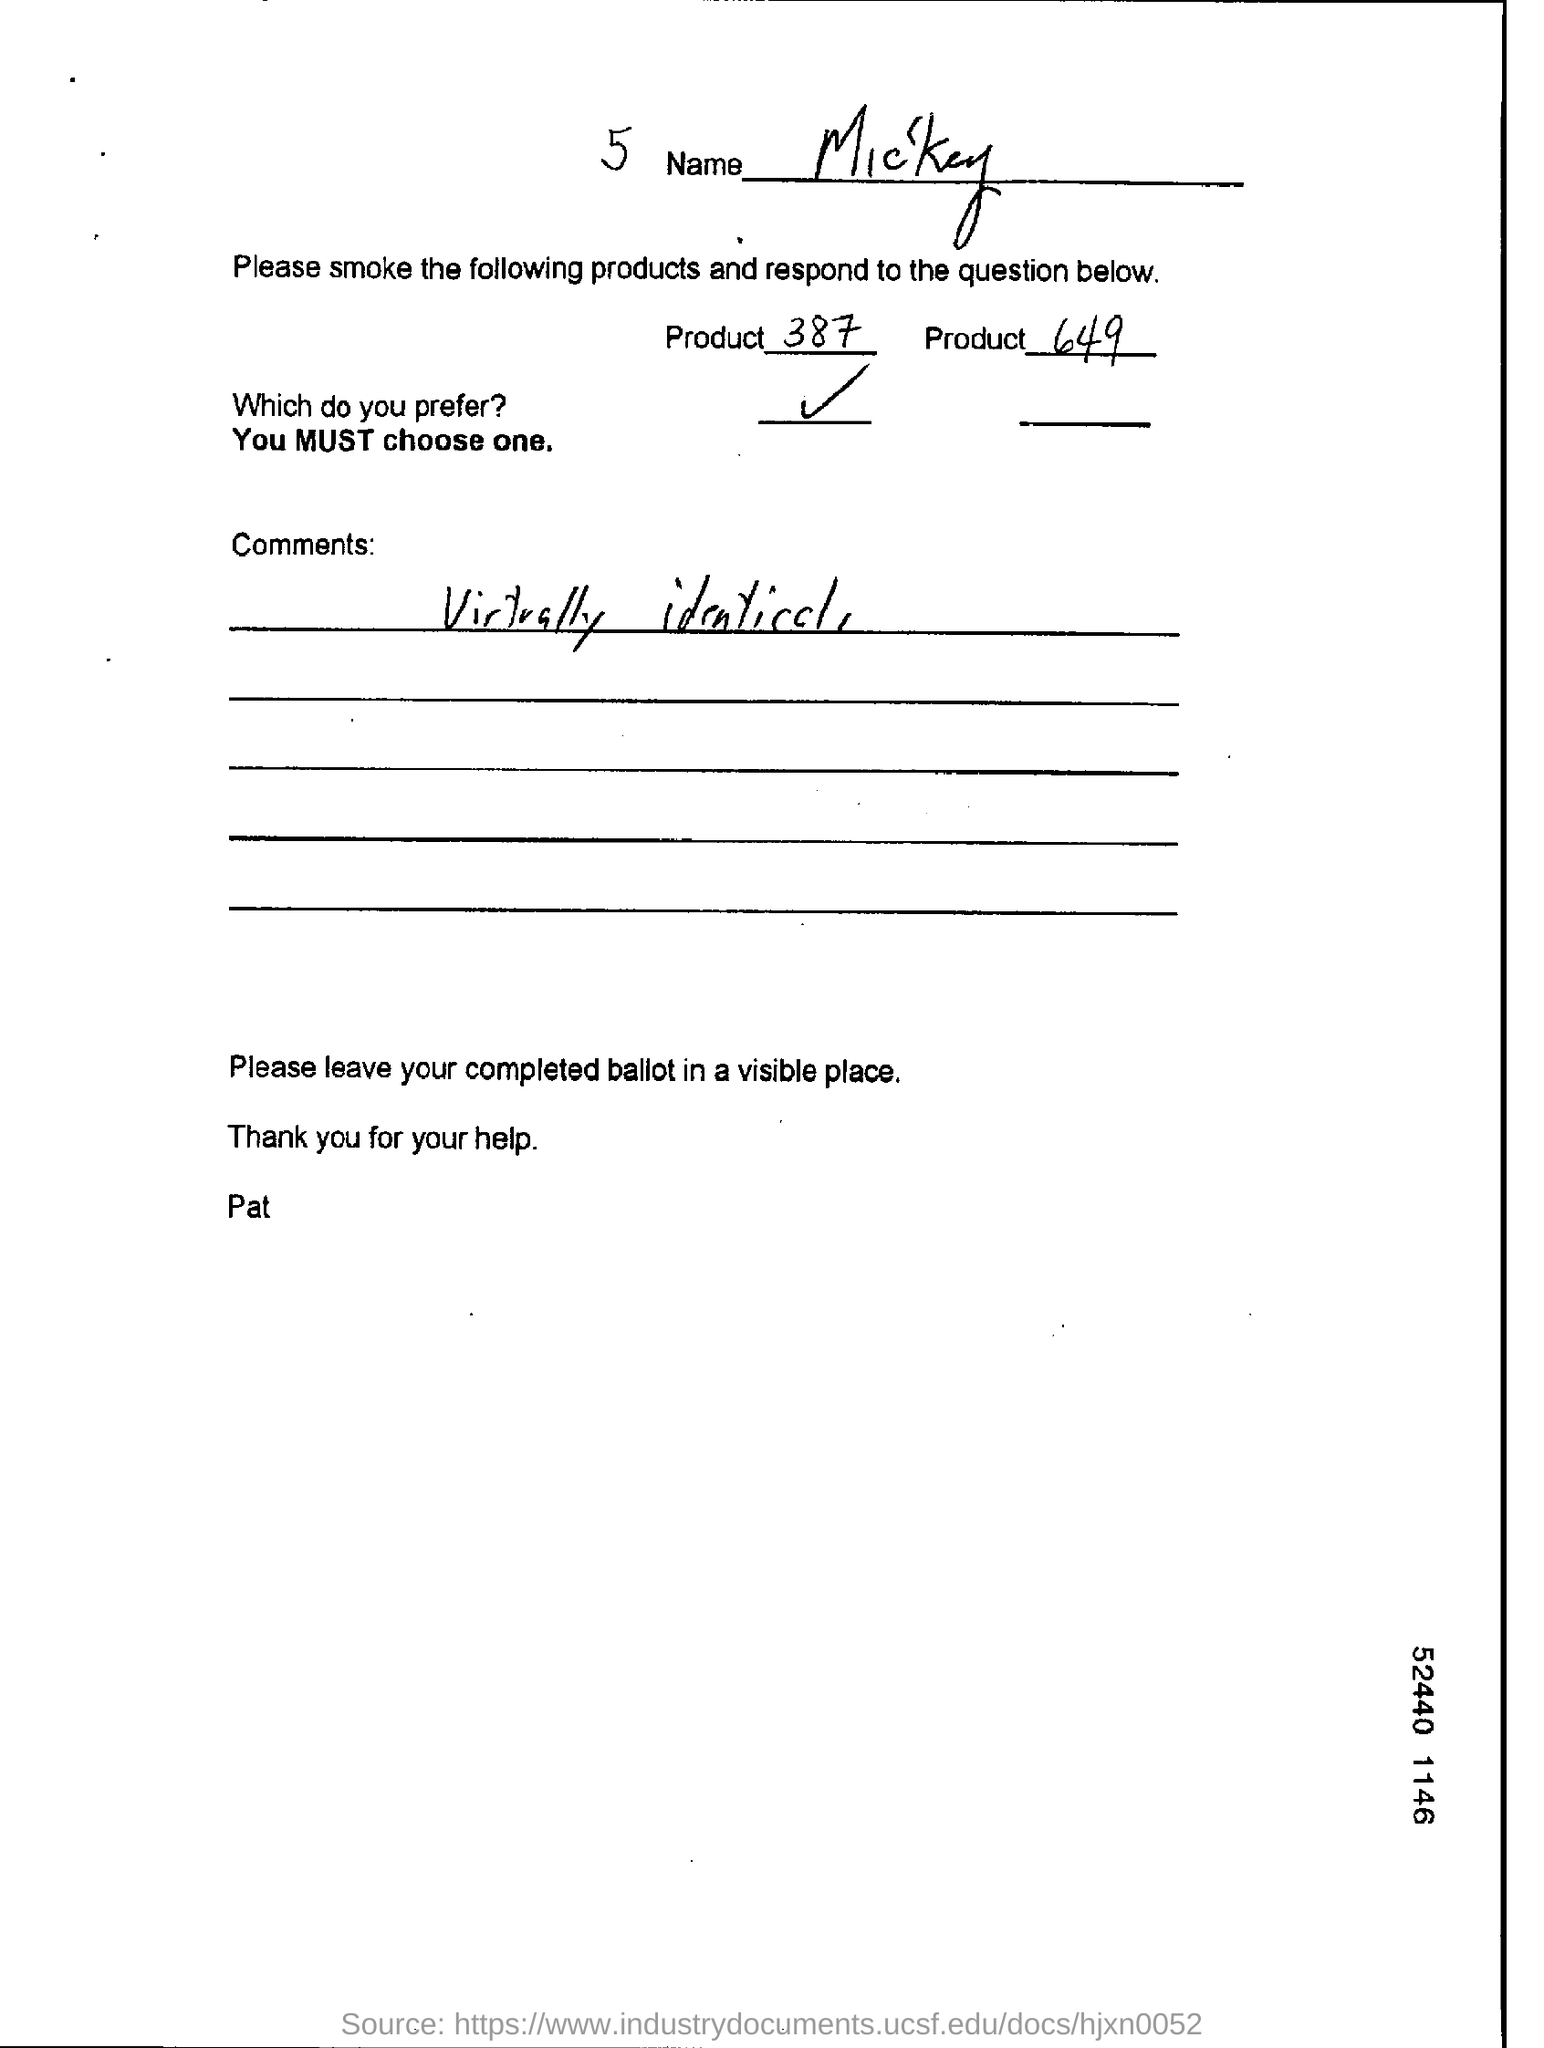Identify some key points in this picture. The form has been signed by 'Pat.' Mickey prefers Product 387. The name given is Mickey. The comment is virtually identical to... 